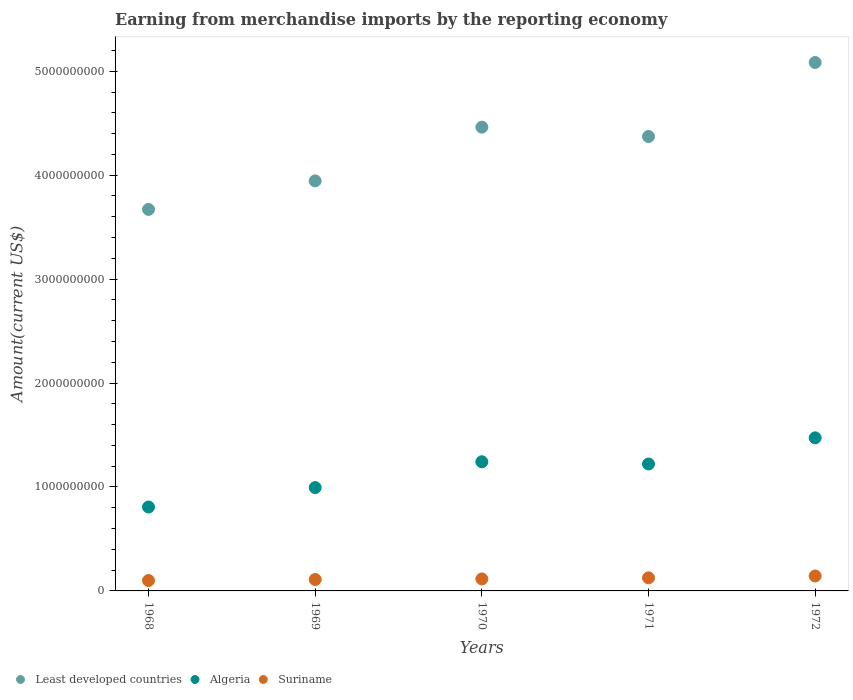What is the amount earned from merchandise imports in Least developed countries in 1972?
Keep it short and to the point. 5.08e+09. Across all years, what is the maximum amount earned from merchandise imports in Least developed countries?
Provide a short and direct response. 5.08e+09. Across all years, what is the minimum amount earned from merchandise imports in Least developed countries?
Keep it short and to the point. 3.67e+09. In which year was the amount earned from merchandise imports in Least developed countries maximum?
Make the answer very short. 1972. In which year was the amount earned from merchandise imports in Least developed countries minimum?
Your answer should be compact. 1968. What is the total amount earned from merchandise imports in Algeria in the graph?
Offer a very short reply. 5.74e+09. What is the difference between the amount earned from merchandise imports in Algeria in 1969 and that in 1970?
Provide a short and direct response. -2.48e+08. What is the difference between the amount earned from merchandise imports in Algeria in 1971 and the amount earned from merchandise imports in Least developed countries in 1968?
Your answer should be compact. -2.45e+09. What is the average amount earned from merchandise imports in Algeria per year?
Provide a short and direct response. 1.15e+09. In the year 1969, what is the difference between the amount earned from merchandise imports in Least developed countries and amount earned from merchandise imports in Suriname?
Your response must be concise. 3.84e+09. What is the ratio of the amount earned from merchandise imports in Least developed countries in 1968 to that in 1971?
Give a very brief answer. 0.84. What is the difference between the highest and the second highest amount earned from merchandise imports in Least developed countries?
Your answer should be compact. 6.22e+08. What is the difference between the highest and the lowest amount earned from merchandise imports in Algeria?
Offer a terse response. 6.66e+08. Is it the case that in every year, the sum of the amount earned from merchandise imports in Algeria and amount earned from merchandise imports in Suriname  is greater than the amount earned from merchandise imports in Least developed countries?
Keep it short and to the point. No. Does the graph contain any zero values?
Ensure brevity in your answer.  No. Where does the legend appear in the graph?
Provide a short and direct response. Bottom left. What is the title of the graph?
Your response must be concise. Earning from merchandise imports by the reporting economy. Does "Turkey" appear as one of the legend labels in the graph?
Provide a succinct answer. No. What is the label or title of the Y-axis?
Give a very brief answer. Amount(current US$). What is the Amount(current US$) of Least developed countries in 1968?
Give a very brief answer. 3.67e+09. What is the Amount(current US$) of Algeria in 1968?
Keep it short and to the point. 8.07e+08. What is the Amount(current US$) in Suriname in 1968?
Give a very brief answer. 1.00e+08. What is the Amount(current US$) of Least developed countries in 1969?
Give a very brief answer. 3.95e+09. What is the Amount(current US$) in Algeria in 1969?
Offer a very short reply. 9.94e+08. What is the Amount(current US$) in Suriname in 1969?
Give a very brief answer. 1.10e+08. What is the Amount(current US$) of Least developed countries in 1970?
Your answer should be compact. 4.46e+09. What is the Amount(current US$) in Algeria in 1970?
Keep it short and to the point. 1.24e+09. What is the Amount(current US$) of Suriname in 1970?
Make the answer very short. 1.15e+08. What is the Amount(current US$) in Least developed countries in 1971?
Your response must be concise. 4.37e+09. What is the Amount(current US$) in Algeria in 1971?
Keep it short and to the point. 1.22e+09. What is the Amount(current US$) of Suriname in 1971?
Provide a short and direct response. 1.26e+08. What is the Amount(current US$) in Least developed countries in 1972?
Offer a very short reply. 5.08e+09. What is the Amount(current US$) in Algeria in 1972?
Your answer should be compact. 1.47e+09. What is the Amount(current US$) in Suriname in 1972?
Your answer should be compact. 1.44e+08. Across all years, what is the maximum Amount(current US$) of Least developed countries?
Offer a terse response. 5.08e+09. Across all years, what is the maximum Amount(current US$) in Algeria?
Ensure brevity in your answer.  1.47e+09. Across all years, what is the maximum Amount(current US$) in Suriname?
Provide a short and direct response. 1.44e+08. Across all years, what is the minimum Amount(current US$) of Least developed countries?
Provide a short and direct response. 3.67e+09. Across all years, what is the minimum Amount(current US$) of Algeria?
Provide a short and direct response. 8.07e+08. Across all years, what is the minimum Amount(current US$) in Suriname?
Ensure brevity in your answer.  1.00e+08. What is the total Amount(current US$) in Least developed countries in the graph?
Your answer should be compact. 2.15e+1. What is the total Amount(current US$) of Algeria in the graph?
Provide a succinct answer. 5.74e+09. What is the total Amount(current US$) of Suriname in the graph?
Your answer should be compact. 5.95e+08. What is the difference between the Amount(current US$) of Least developed countries in 1968 and that in 1969?
Keep it short and to the point. -2.75e+08. What is the difference between the Amount(current US$) in Algeria in 1968 and that in 1969?
Your response must be concise. -1.87e+08. What is the difference between the Amount(current US$) in Suriname in 1968 and that in 1969?
Ensure brevity in your answer.  -1.01e+07. What is the difference between the Amount(current US$) in Least developed countries in 1968 and that in 1970?
Keep it short and to the point. -7.91e+08. What is the difference between the Amount(current US$) of Algeria in 1968 and that in 1970?
Give a very brief answer. -4.35e+08. What is the difference between the Amount(current US$) of Suriname in 1968 and that in 1970?
Your response must be concise. -1.55e+07. What is the difference between the Amount(current US$) of Least developed countries in 1968 and that in 1971?
Offer a terse response. -7.02e+08. What is the difference between the Amount(current US$) of Algeria in 1968 and that in 1971?
Make the answer very short. -4.14e+08. What is the difference between the Amount(current US$) of Suriname in 1968 and that in 1971?
Make the answer very short. -2.60e+07. What is the difference between the Amount(current US$) in Least developed countries in 1968 and that in 1972?
Make the answer very short. -1.41e+09. What is the difference between the Amount(current US$) of Algeria in 1968 and that in 1972?
Provide a short and direct response. -6.66e+08. What is the difference between the Amount(current US$) of Suriname in 1968 and that in 1972?
Keep it short and to the point. -4.37e+07. What is the difference between the Amount(current US$) of Least developed countries in 1969 and that in 1970?
Provide a short and direct response. -5.17e+08. What is the difference between the Amount(current US$) of Algeria in 1969 and that in 1970?
Offer a terse response. -2.48e+08. What is the difference between the Amount(current US$) of Suriname in 1969 and that in 1970?
Make the answer very short. -5.35e+06. What is the difference between the Amount(current US$) in Least developed countries in 1969 and that in 1971?
Make the answer very short. -4.27e+08. What is the difference between the Amount(current US$) in Algeria in 1969 and that in 1971?
Ensure brevity in your answer.  -2.27e+08. What is the difference between the Amount(current US$) of Suriname in 1969 and that in 1971?
Ensure brevity in your answer.  -1.59e+07. What is the difference between the Amount(current US$) in Least developed countries in 1969 and that in 1972?
Your answer should be very brief. -1.14e+09. What is the difference between the Amount(current US$) in Algeria in 1969 and that in 1972?
Offer a terse response. -4.79e+08. What is the difference between the Amount(current US$) of Suriname in 1969 and that in 1972?
Ensure brevity in your answer.  -3.36e+07. What is the difference between the Amount(current US$) of Least developed countries in 1970 and that in 1971?
Offer a terse response. 8.99e+07. What is the difference between the Amount(current US$) of Algeria in 1970 and that in 1971?
Give a very brief answer. 2.15e+07. What is the difference between the Amount(current US$) of Suriname in 1970 and that in 1971?
Offer a very short reply. -1.05e+07. What is the difference between the Amount(current US$) in Least developed countries in 1970 and that in 1972?
Give a very brief answer. -6.22e+08. What is the difference between the Amount(current US$) in Algeria in 1970 and that in 1972?
Offer a terse response. -2.30e+08. What is the difference between the Amount(current US$) in Suriname in 1970 and that in 1972?
Offer a very short reply. -2.83e+07. What is the difference between the Amount(current US$) in Least developed countries in 1971 and that in 1972?
Provide a short and direct response. -7.12e+08. What is the difference between the Amount(current US$) of Algeria in 1971 and that in 1972?
Offer a very short reply. -2.52e+08. What is the difference between the Amount(current US$) in Suriname in 1971 and that in 1972?
Make the answer very short. -1.78e+07. What is the difference between the Amount(current US$) of Least developed countries in 1968 and the Amount(current US$) of Algeria in 1969?
Your response must be concise. 2.68e+09. What is the difference between the Amount(current US$) of Least developed countries in 1968 and the Amount(current US$) of Suriname in 1969?
Offer a very short reply. 3.56e+09. What is the difference between the Amount(current US$) in Algeria in 1968 and the Amount(current US$) in Suriname in 1969?
Provide a succinct answer. 6.97e+08. What is the difference between the Amount(current US$) of Least developed countries in 1968 and the Amount(current US$) of Algeria in 1970?
Give a very brief answer. 2.43e+09. What is the difference between the Amount(current US$) in Least developed countries in 1968 and the Amount(current US$) in Suriname in 1970?
Offer a very short reply. 3.56e+09. What is the difference between the Amount(current US$) of Algeria in 1968 and the Amount(current US$) of Suriname in 1970?
Keep it short and to the point. 6.92e+08. What is the difference between the Amount(current US$) in Least developed countries in 1968 and the Amount(current US$) in Algeria in 1971?
Offer a very short reply. 2.45e+09. What is the difference between the Amount(current US$) in Least developed countries in 1968 and the Amount(current US$) in Suriname in 1971?
Provide a short and direct response. 3.54e+09. What is the difference between the Amount(current US$) in Algeria in 1968 and the Amount(current US$) in Suriname in 1971?
Your answer should be very brief. 6.81e+08. What is the difference between the Amount(current US$) in Least developed countries in 1968 and the Amount(current US$) in Algeria in 1972?
Provide a short and direct response. 2.20e+09. What is the difference between the Amount(current US$) of Least developed countries in 1968 and the Amount(current US$) of Suriname in 1972?
Offer a terse response. 3.53e+09. What is the difference between the Amount(current US$) of Algeria in 1968 and the Amount(current US$) of Suriname in 1972?
Keep it short and to the point. 6.64e+08. What is the difference between the Amount(current US$) of Least developed countries in 1969 and the Amount(current US$) of Algeria in 1970?
Offer a terse response. 2.70e+09. What is the difference between the Amount(current US$) in Least developed countries in 1969 and the Amount(current US$) in Suriname in 1970?
Ensure brevity in your answer.  3.83e+09. What is the difference between the Amount(current US$) of Algeria in 1969 and the Amount(current US$) of Suriname in 1970?
Your response must be concise. 8.79e+08. What is the difference between the Amount(current US$) of Least developed countries in 1969 and the Amount(current US$) of Algeria in 1971?
Your answer should be very brief. 2.72e+09. What is the difference between the Amount(current US$) in Least developed countries in 1969 and the Amount(current US$) in Suriname in 1971?
Offer a very short reply. 3.82e+09. What is the difference between the Amount(current US$) of Algeria in 1969 and the Amount(current US$) of Suriname in 1971?
Ensure brevity in your answer.  8.68e+08. What is the difference between the Amount(current US$) in Least developed countries in 1969 and the Amount(current US$) in Algeria in 1972?
Your response must be concise. 2.47e+09. What is the difference between the Amount(current US$) in Least developed countries in 1969 and the Amount(current US$) in Suriname in 1972?
Ensure brevity in your answer.  3.80e+09. What is the difference between the Amount(current US$) of Algeria in 1969 and the Amount(current US$) of Suriname in 1972?
Your answer should be very brief. 8.51e+08. What is the difference between the Amount(current US$) in Least developed countries in 1970 and the Amount(current US$) in Algeria in 1971?
Provide a succinct answer. 3.24e+09. What is the difference between the Amount(current US$) of Least developed countries in 1970 and the Amount(current US$) of Suriname in 1971?
Your answer should be very brief. 4.34e+09. What is the difference between the Amount(current US$) of Algeria in 1970 and the Amount(current US$) of Suriname in 1971?
Your response must be concise. 1.12e+09. What is the difference between the Amount(current US$) in Least developed countries in 1970 and the Amount(current US$) in Algeria in 1972?
Make the answer very short. 2.99e+09. What is the difference between the Amount(current US$) of Least developed countries in 1970 and the Amount(current US$) of Suriname in 1972?
Provide a short and direct response. 4.32e+09. What is the difference between the Amount(current US$) in Algeria in 1970 and the Amount(current US$) in Suriname in 1972?
Your response must be concise. 1.10e+09. What is the difference between the Amount(current US$) in Least developed countries in 1971 and the Amount(current US$) in Algeria in 1972?
Your answer should be compact. 2.90e+09. What is the difference between the Amount(current US$) in Least developed countries in 1971 and the Amount(current US$) in Suriname in 1972?
Your answer should be very brief. 4.23e+09. What is the difference between the Amount(current US$) in Algeria in 1971 and the Amount(current US$) in Suriname in 1972?
Ensure brevity in your answer.  1.08e+09. What is the average Amount(current US$) of Least developed countries per year?
Offer a terse response. 4.31e+09. What is the average Amount(current US$) in Algeria per year?
Provide a succinct answer. 1.15e+09. What is the average Amount(current US$) in Suriname per year?
Offer a terse response. 1.19e+08. In the year 1968, what is the difference between the Amount(current US$) of Least developed countries and Amount(current US$) of Algeria?
Offer a terse response. 2.86e+09. In the year 1968, what is the difference between the Amount(current US$) of Least developed countries and Amount(current US$) of Suriname?
Keep it short and to the point. 3.57e+09. In the year 1968, what is the difference between the Amount(current US$) in Algeria and Amount(current US$) in Suriname?
Provide a short and direct response. 7.07e+08. In the year 1969, what is the difference between the Amount(current US$) of Least developed countries and Amount(current US$) of Algeria?
Keep it short and to the point. 2.95e+09. In the year 1969, what is the difference between the Amount(current US$) of Least developed countries and Amount(current US$) of Suriname?
Offer a terse response. 3.84e+09. In the year 1969, what is the difference between the Amount(current US$) in Algeria and Amount(current US$) in Suriname?
Provide a succinct answer. 8.84e+08. In the year 1970, what is the difference between the Amount(current US$) in Least developed countries and Amount(current US$) in Algeria?
Keep it short and to the point. 3.22e+09. In the year 1970, what is the difference between the Amount(current US$) of Least developed countries and Amount(current US$) of Suriname?
Ensure brevity in your answer.  4.35e+09. In the year 1970, what is the difference between the Amount(current US$) of Algeria and Amount(current US$) of Suriname?
Offer a terse response. 1.13e+09. In the year 1971, what is the difference between the Amount(current US$) in Least developed countries and Amount(current US$) in Algeria?
Your answer should be very brief. 3.15e+09. In the year 1971, what is the difference between the Amount(current US$) of Least developed countries and Amount(current US$) of Suriname?
Ensure brevity in your answer.  4.25e+09. In the year 1971, what is the difference between the Amount(current US$) of Algeria and Amount(current US$) of Suriname?
Your answer should be very brief. 1.10e+09. In the year 1972, what is the difference between the Amount(current US$) in Least developed countries and Amount(current US$) in Algeria?
Provide a succinct answer. 3.61e+09. In the year 1972, what is the difference between the Amount(current US$) of Least developed countries and Amount(current US$) of Suriname?
Your answer should be compact. 4.94e+09. In the year 1972, what is the difference between the Amount(current US$) in Algeria and Amount(current US$) in Suriname?
Offer a terse response. 1.33e+09. What is the ratio of the Amount(current US$) in Least developed countries in 1968 to that in 1969?
Provide a short and direct response. 0.93. What is the ratio of the Amount(current US$) of Algeria in 1968 to that in 1969?
Your answer should be compact. 0.81. What is the ratio of the Amount(current US$) of Suriname in 1968 to that in 1969?
Your answer should be compact. 0.91. What is the ratio of the Amount(current US$) of Least developed countries in 1968 to that in 1970?
Provide a succinct answer. 0.82. What is the ratio of the Amount(current US$) in Algeria in 1968 to that in 1970?
Ensure brevity in your answer.  0.65. What is the ratio of the Amount(current US$) of Suriname in 1968 to that in 1970?
Give a very brief answer. 0.87. What is the ratio of the Amount(current US$) in Least developed countries in 1968 to that in 1971?
Your answer should be compact. 0.84. What is the ratio of the Amount(current US$) in Algeria in 1968 to that in 1971?
Ensure brevity in your answer.  0.66. What is the ratio of the Amount(current US$) of Suriname in 1968 to that in 1971?
Your answer should be very brief. 0.79. What is the ratio of the Amount(current US$) of Least developed countries in 1968 to that in 1972?
Your response must be concise. 0.72. What is the ratio of the Amount(current US$) of Algeria in 1968 to that in 1972?
Your response must be concise. 0.55. What is the ratio of the Amount(current US$) in Suriname in 1968 to that in 1972?
Offer a terse response. 0.7. What is the ratio of the Amount(current US$) in Least developed countries in 1969 to that in 1970?
Ensure brevity in your answer.  0.88. What is the ratio of the Amount(current US$) of Algeria in 1969 to that in 1970?
Your response must be concise. 0.8. What is the ratio of the Amount(current US$) of Suriname in 1969 to that in 1970?
Provide a succinct answer. 0.95. What is the ratio of the Amount(current US$) of Least developed countries in 1969 to that in 1971?
Your response must be concise. 0.9. What is the ratio of the Amount(current US$) of Algeria in 1969 to that in 1971?
Your response must be concise. 0.81. What is the ratio of the Amount(current US$) of Suriname in 1969 to that in 1971?
Keep it short and to the point. 0.87. What is the ratio of the Amount(current US$) in Least developed countries in 1969 to that in 1972?
Make the answer very short. 0.78. What is the ratio of the Amount(current US$) of Algeria in 1969 to that in 1972?
Your response must be concise. 0.68. What is the ratio of the Amount(current US$) in Suriname in 1969 to that in 1972?
Make the answer very short. 0.77. What is the ratio of the Amount(current US$) of Least developed countries in 1970 to that in 1971?
Your answer should be very brief. 1.02. What is the ratio of the Amount(current US$) of Algeria in 1970 to that in 1971?
Offer a terse response. 1.02. What is the ratio of the Amount(current US$) in Suriname in 1970 to that in 1971?
Offer a terse response. 0.92. What is the ratio of the Amount(current US$) in Least developed countries in 1970 to that in 1972?
Your answer should be very brief. 0.88. What is the ratio of the Amount(current US$) of Algeria in 1970 to that in 1972?
Offer a terse response. 0.84. What is the ratio of the Amount(current US$) in Suriname in 1970 to that in 1972?
Offer a very short reply. 0.8. What is the ratio of the Amount(current US$) of Least developed countries in 1971 to that in 1972?
Keep it short and to the point. 0.86. What is the ratio of the Amount(current US$) in Algeria in 1971 to that in 1972?
Keep it short and to the point. 0.83. What is the ratio of the Amount(current US$) in Suriname in 1971 to that in 1972?
Your answer should be very brief. 0.88. What is the difference between the highest and the second highest Amount(current US$) of Least developed countries?
Your response must be concise. 6.22e+08. What is the difference between the highest and the second highest Amount(current US$) of Algeria?
Provide a succinct answer. 2.30e+08. What is the difference between the highest and the second highest Amount(current US$) of Suriname?
Make the answer very short. 1.78e+07. What is the difference between the highest and the lowest Amount(current US$) of Least developed countries?
Ensure brevity in your answer.  1.41e+09. What is the difference between the highest and the lowest Amount(current US$) of Algeria?
Make the answer very short. 6.66e+08. What is the difference between the highest and the lowest Amount(current US$) in Suriname?
Ensure brevity in your answer.  4.37e+07. 